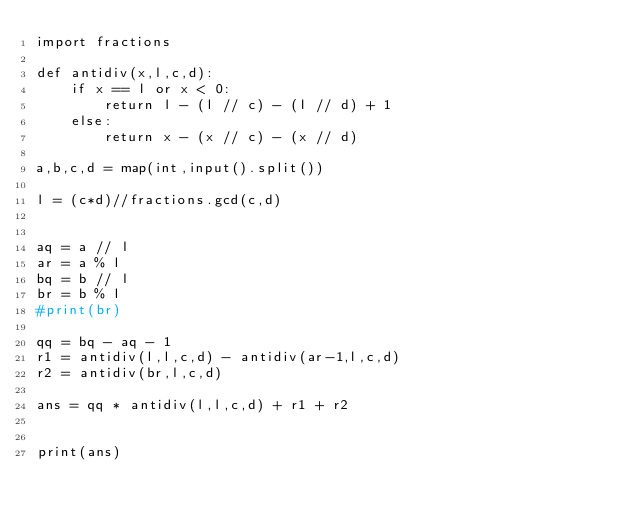<code> <loc_0><loc_0><loc_500><loc_500><_Python_>import fractions

def antidiv(x,l,c,d):
    if x == l or x < 0:
        return l - (l // c) - (l // d) + 1
    else:
        return x - (x // c) - (x // d) 

a,b,c,d = map(int,input().split())

l = (c*d)//fractions.gcd(c,d)


aq = a // l
ar = a % l
bq = b // l
br = b % l
#print(br)

qq = bq - aq - 1
r1 = antidiv(l,l,c,d) - antidiv(ar-1,l,c,d)
r2 = antidiv(br,l,c,d)

ans = qq * antidiv(l,l,c,d) + r1 + r2


print(ans)
</code> 